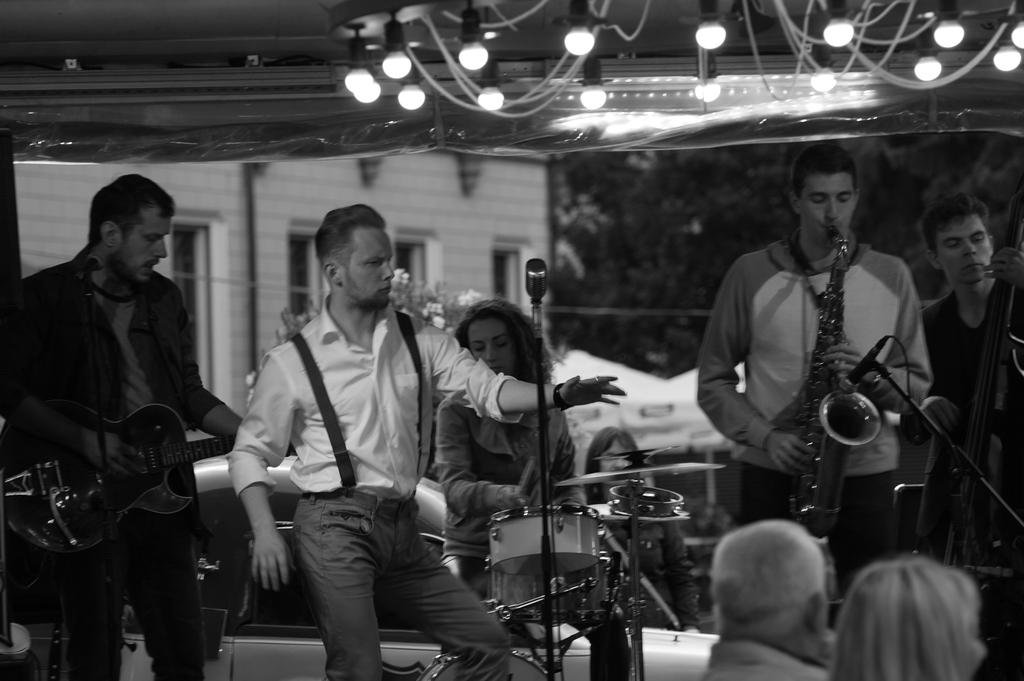How many people are in the image? There is a group of persons in the image. What are the persons in the image doing? The persons are playing musical instruments. Can you hear the music being played by the persons in the image? The image is a visual representation, so we cannot hear any music being played. Is there an airplane visible in the image? There is no mention of an airplane in the provided facts, so we cannot determine if one is present in the image. 